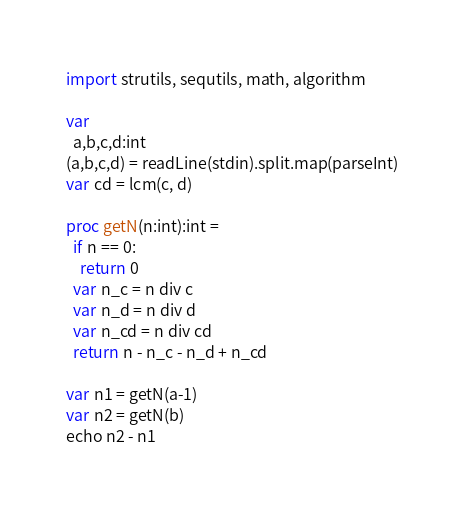Convert code to text. <code><loc_0><loc_0><loc_500><loc_500><_Nim_>import strutils, sequtils, math, algorithm

var
  a,b,c,d:int
(a,b,c,d) = readLine(stdin).split.map(parseInt)
var cd = lcm(c, d)

proc getN(n:int):int =
  if n == 0:
    return 0
  var n_c = n div c
  var n_d = n div d
  var n_cd = n div cd
  return n - n_c - n_d + n_cd

var n1 = getN(a-1)
var n2 = getN(b)
echo n2 - n1
</code> 